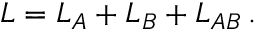Convert formula to latex. <formula><loc_0><loc_0><loc_500><loc_500>L = L _ { A } + L _ { B } + L _ { A B } \, .</formula> 